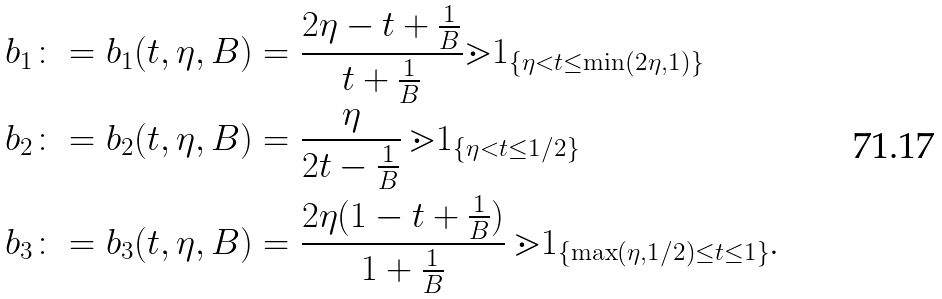<formula> <loc_0><loc_0><loc_500><loc_500>b _ { 1 } \colon = b _ { 1 } ( t , \eta , B ) & = \frac { 2 \eta - t + \frac { 1 } { B } } { t + \frac { 1 } { B } } \mathbb { m } { 1 } _ { \{ \eta < t \leq \min ( 2 \eta , 1 ) \} } \\ b _ { 2 } \colon = b _ { 2 } ( t , \eta , B ) & = \frac { \eta } { 2 t - \frac { 1 } { B } } \, \mathbb { m } { 1 } _ { \{ \eta < t \leq 1 / 2 \} } \\ b _ { 3 } \colon = b _ { 3 } ( t , \eta , B ) & = \frac { 2 \eta ( 1 - t + \frac { 1 } { B } ) } { 1 + \frac { 1 } { B } } \, \mathbb { m } { 1 } _ { \{ \max ( \eta , 1 / 2 ) \leq t \leq 1 \} } .</formula> 